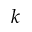Convert formula to latex. <formula><loc_0><loc_0><loc_500><loc_500>k</formula> 